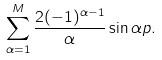<formula> <loc_0><loc_0><loc_500><loc_500>\sum _ { \alpha = 1 } ^ { M } \frac { 2 ( - 1 ) ^ { \alpha - 1 } } { \alpha } \sin \alpha p .</formula> 